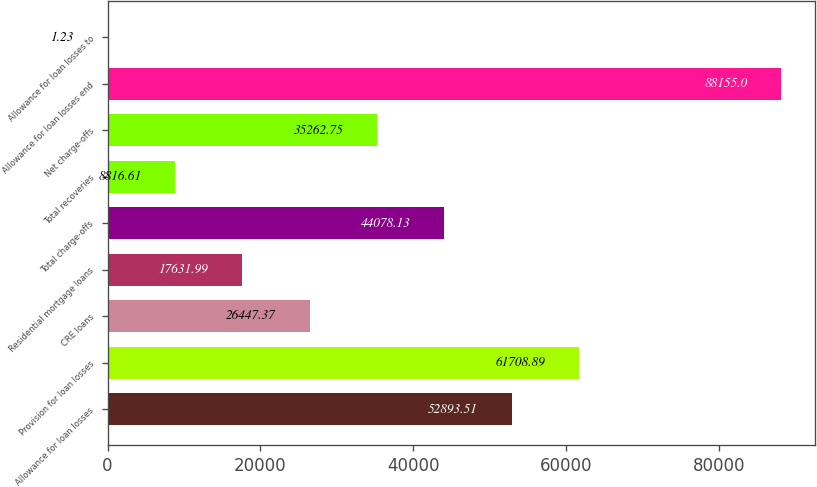<chart> <loc_0><loc_0><loc_500><loc_500><bar_chart><fcel>Allowance for loan losses<fcel>Provision for loan losses<fcel>CRE loans<fcel>Residential mortgage loans<fcel>Total charge-offs<fcel>Total recoveries<fcel>Net charge-offs<fcel>Allowance for loan losses end<fcel>Allowance for loan losses to<nl><fcel>52893.5<fcel>61708.9<fcel>26447.4<fcel>17632<fcel>44078.1<fcel>8816.61<fcel>35262.8<fcel>88155<fcel>1.23<nl></chart> 